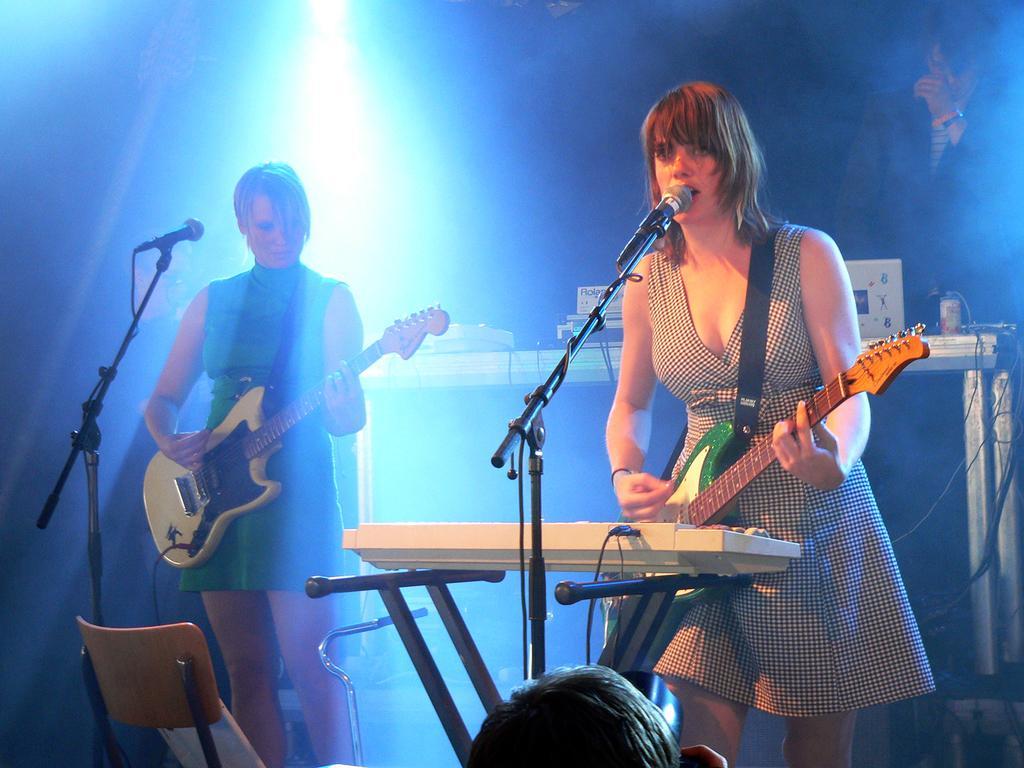Please provide a concise description of this image. In this picture we can see there are three people standing on the path and the two women are holding the guitars and a woman is singing a song. In front of the women there are microphones with standards and a chair. Behind the people there are some musical instruments and a light. 